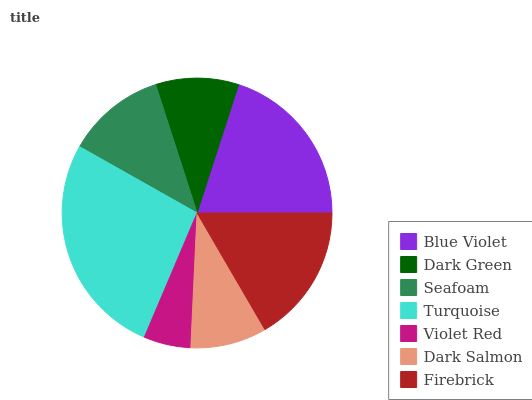Is Violet Red the minimum?
Answer yes or no. Yes. Is Turquoise the maximum?
Answer yes or no. Yes. Is Dark Green the minimum?
Answer yes or no. No. Is Dark Green the maximum?
Answer yes or no. No. Is Blue Violet greater than Dark Green?
Answer yes or no. Yes. Is Dark Green less than Blue Violet?
Answer yes or no. Yes. Is Dark Green greater than Blue Violet?
Answer yes or no. No. Is Blue Violet less than Dark Green?
Answer yes or no. No. Is Seafoam the high median?
Answer yes or no. Yes. Is Seafoam the low median?
Answer yes or no. Yes. Is Dark Salmon the high median?
Answer yes or no. No. Is Firebrick the low median?
Answer yes or no. No. 